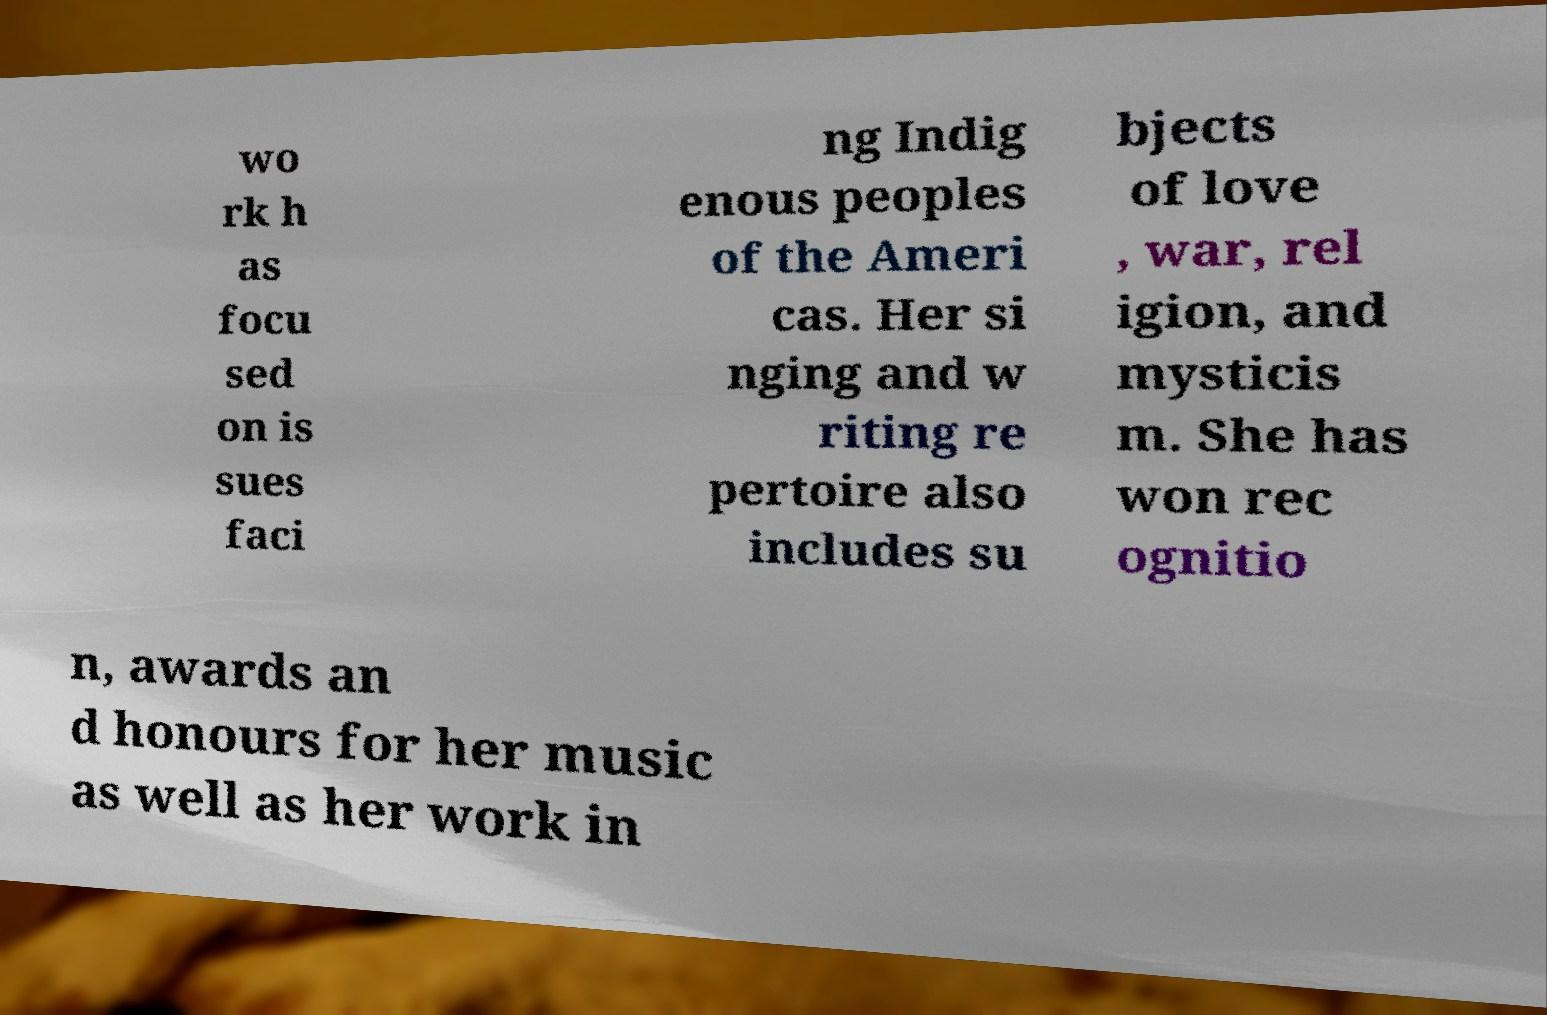Please identify and transcribe the text found in this image. wo rk h as focu sed on is sues faci ng Indig enous peoples of the Ameri cas. Her si nging and w riting re pertoire also includes su bjects of love , war, rel igion, and mysticis m. She has won rec ognitio n, awards an d honours for her music as well as her work in 